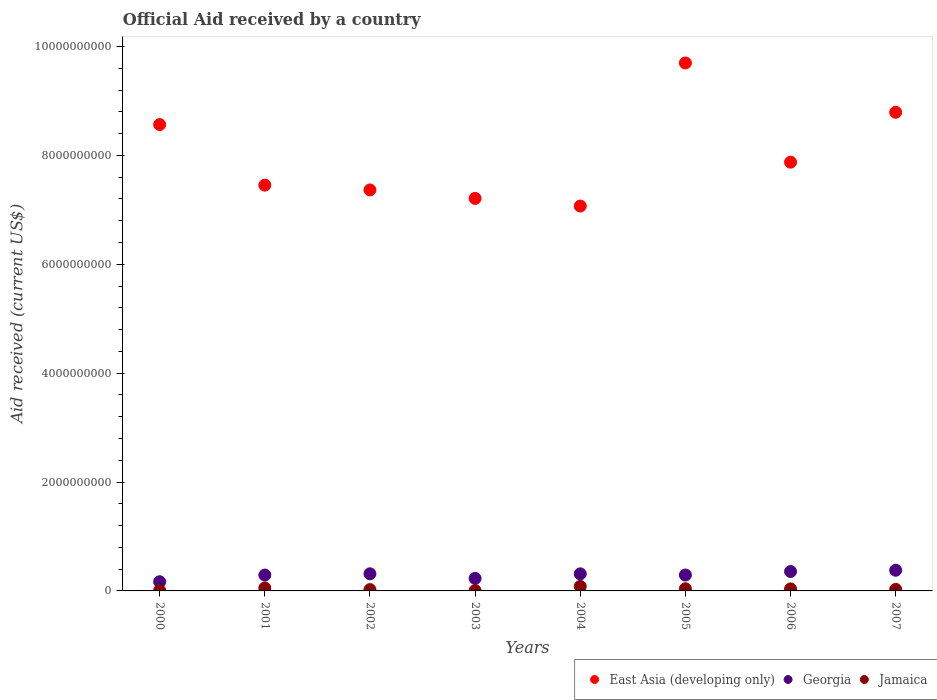How many different coloured dotlines are there?
Your response must be concise. 3. What is the net official aid received in Georgia in 2004?
Your response must be concise. 3.13e+08. Across all years, what is the maximum net official aid received in Jamaica?
Offer a very short reply. 8.26e+07. Across all years, what is the minimum net official aid received in Georgia?
Offer a terse response. 1.69e+08. What is the total net official aid received in Georgia in the graph?
Offer a very short reply. 2.35e+09. What is the difference between the net official aid received in Jamaica in 2002 and that in 2005?
Give a very brief answer. -1.56e+07. What is the difference between the net official aid received in Jamaica in 2002 and the net official aid received in Georgia in 2000?
Offer a terse response. -1.45e+08. What is the average net official aid received in East Asia (developing only) per year?
Provide a short and direct response. 8.00e+09. In the year 2006, what is the difference between the net official aid received in East Asia (developing only) and net official aid received in Georgia?
Make the answer very short. 7.52e+09. In how many years, is the net official aid received in East Asia (developing only) greater than 7200000000 US$?
Provide a short and direct response. 7. What is the ratio of the net official aid received in Georgia in 2000 to that in 2005?
Your answer should be very brief. 0.58. Is the net official aid received in Jamaica in 2004 less than that in 2007?
Make the answer very short. No. What is the difference between the highest and the second highest net official aid received in Jamaica?
Provide a succinct answer. 2.86e+07. What is the difference between the highest and the lowest net official aid received in Jamaica?
Make the answer very short. 7.61e+07. Is the sum of the net official aid received in East Asia (developing only) in 2000 and 2001 greater than the maximum net official aid received in Jamaica across all years?
Provide a short and direct response. Yes. Is it the case that in every year, the sum of the net official aid received in Georgia and net official aid received in East Asia (developing only)  is greater than the net official aid received in Jamaica?
Your answer should be very brief. Yes. Is the net official aid received in East Asia (developing only) strictly greater than the net official aid received in Jamaica over the years?
Provide a short and direct response. Yes. How many years are there in the graph?
Provide a succinct answer. 8. What is the difference between two consecutive major ticks on the Y-axis?
Your answer should be very brief. 2.00e+09. Are the values on the major ticks of Y-axis written in scientific E-notation?
Ensure brevity in your answer.  No. Where does the legend appear in the graph?
Your answer should be compact. Bottom right. What is the title of the graph?
Your answer should be very brief. Official Aid received by a country. Does "Lithuania" appear as one of the legend labels in the graph?
Your response must be concise. No. What is the label or title of the X-axis?
Your answer should be very brief. Years. What is the label or title of the Y-axis?
Make the answer very short. Aid received (current US$). What is the Aid received (current US$) of East Asia (developing only) in 2000?
Offer a terse response. 8.57e+09. What is the Aid received (current US$) in Georgia in 2000?
Provide a short and direct response. 1.69e+08. What is the Aid received (current US$) of Jamaica in 2000?
Give a very brief answer. 8.56e+06. What is the Aid received (current US$) in East Asia (developing only) in 2001?
Offer a very short reply. 7.45e+09. What is the Aid received (current US$) of Georgia in 2001?
Offer a terse response. 2.91e+08. What is the Aid received (current US$) of Jamaica in 2001?
Your response must be concise. 5.40e+07. What is the Aid received (current US$) in East Asia (developing only) in 2002?
Keep it short and to the point. 7.36e+09. What is the Aid received (current US$) in Georgia in 2002?
Your answer should be very brief. 3.14e+08. What is the Aid received (current US$) of Jamaica in 2002?
Make the answer very short. 2.40e+07. What is the Aid received (current US$) in East Asia (developing only) in 2003?
Your answer should be very brief. 7.21e+09. What is the Aid received (current US$) in Georgia in 2003?
Give a very brief answer. 2.30e+08. What is the Aid received (current US$) in Jamaica in 2003?
Offer a very short reply. 6.52e+06. What is the Aid received (current US$) of East Asia (developing only) in 2004?
Give a very brief answer. 7.07e+09. What is the Aid received (current US$) in Georgia in 2004?
Offer a very short reply. 3.13e+08. What is the Aid received (current US$) in Jamaica in 2004?
Make the answer very short. 8.26e+07. What is the Aid received (current US$) in East Asia (developing only) in 2005?
Your answer should be compact. 9.70e+09. What is the Aid received (current US$) in Georgia in 2005?
Offer a terse response. 2.92e+08. What is the Aid received (current US$) of Jamaica in 2005?
Provide a succinct answer. 3.96e+07. What is the Aid received (current US$) of East Asia (developing only) in 2006?
Ensure brevity in your answer.  7.87e+09. What is the Aid received (current US$) of Georgia in 2006?
Offer a very short reply. 3.56e+08. What is the Aid received (current US$) of Jamaica in 2006?
Your answer should be compact. 3.72e+07. What is the Aid received (current US$) in East Asia (developing only) in 2007?
Give a very brief answer. 8.79e+09. What is the Aid received (current US$) in Georgia in 2007?
Give a very brief answer. 3.80e+08. What is the Aid received (current US$) in Jamaica in 2007?
Your answer should be very brief. 2.81e+07. Across all years, what is the maximum Aid received (current US$) of East Asia (developing only)?
Your answer should be compact. 9.70e+09. Across all years, what is the maximum Aid received (current US$) in Georgia?
Provide a succinct answer. 3.80e+08. Across all years, what is the maximum Aid received (current US$) in Jamaica?
Provide a succinct answer. 8.26e+07. Across all years, what is the minimum Aid received (current US$) of East Asia (developing only)?
Offer a terse response. 7.07e+09. Across all years, what is the minimum Aid received (current US$) of Georgia?
Your answer should be very brief. 1.69e+08. Across all years, what is the minimum Aid received (current US$) in Jamaica?
Provide a short and direct response. 6.52e+06. What is the total Aid received (current US$) in East Asia (developing only) in the graph?
Offer a very short reply. 6.40e+1. What is the total Aid received (current US$) of Georgia in the graph?
Keep it short and to the point. 2.35e+09. What is the total Aid received (current US$) of Jamaica in the graph?
Ensure brevity in your answer.  2.81e+08. What is the difference between the Aid received (current US$) in East Asia (developing only) in 2000 and that in 2001?
Your answer should be compact. 1.11e+09. What is the difference between the Aid received (current US$) in Georgia in 2000 and that in 2001?
Provide a short and direct response. -1.22e+08. What is the difference between the Aid received (current US$) in Jamaica in 2000 and that in 2001?
Make the answer very short. -4.54e+07. What is the difference between the Aid received (current US$) in East Asia (developing only) in 2000 and that in 2002?
Provide a succinct answer. 1.20e+09. What is the difference between the Aid received (current US$) in Georgia in 2000 and that in 2002?
Your answer should be very brief. -1.45e+08. What is the difference between the Aid received (current US$) of Jamaica in 2000 and that in 2002?
Provide a short and direct response. -1.55e+07. What is the difference between the Aid received (current US$) in East Asia (developing only) in 2000 and that in 2003?
Offer a terse response. 1.36e+09. What is the difference between the Aid received (current US$) in Georgia in 2000 and that in 2003?
Keep it short and to the point. -6.09e+07. What is the difference between the Aid received (current US$) of Jamaica in 2000 and that in 2003?
Give a very brief answer. 2.04e+06. What is the difference between the Aid received (current US$) in East Asia (developing only) in 2000 and that in 2004?
Your answer should be compact. 1.50e+09. What is the difference between the Aid received (current US$) of Georgia in 2000 and that in 2004?
Your answer should be very brief. -1.44e+08. What is the difference between the Aid received (current US$) in Jamaica in 2000 and that in 2004?
Your answer should be compact. -7.41e+07. What is the difference between the Aid received (current US$) of East Asia (developing only) in 2000 and that in 2005?
Offer a very short reply. -1.13e+09. What is the difference between the Aid received (current US$) in Georgia in 2000 and that in 2005?
Offer a terse response. -1.23e+08. What is the difference between the Aid received (current US$) in Jamaica in 2000 and that in 2005?
Provide a succinct answer. -3.10e+07. What is the difference between the Aid received (current US$) in East Asia (developing only) in 2000 and that in 2006?
Your answer should be compact. 6.91e+08. What is the difference between the Aid received (current US$) in Georgia in 2000 and that in 2006?
Offer a very short reply. -1.87e+08. What is the difference between the Aid received (current US$) in Jamaica in 2000 and that in 2006?
Give a very brief answer. -2.86e+07. What is the difference between the Aid received (current US$) in East Asia (developing only) in 2000 and that in 2007?
Keep it short and to the point. -2.26e+08. What is the difference between the Aid received (current US$) of Georgia in 2000 and that in 2007?
Offer a very short reply. -2.10e+08. What is the difference between the Aid received (current US$) in Jamaica in 2000 and that in 2007?
Provide a succinct answer. -1.95e+07. What is the difference between the Aid received (current US$) in East Asia (developing only) in 2001 and that in 2002?
Make the answer very short. 8.78e+07. What is the difference between the Aid received (current US$) of Georgia in 2001 and that in 2002?
Make the answer very short. -2.31e+07. What is the difference between the Aid received (current US$) of Jamaica in 2001 and that in 2002?
Your response must be concise. 3.00e+07. What is the difference between the Aid received (current US$) of East Asia (developing only) in 2001 and that in 2003?
Keep it short and to the point. 2.44e+08. What is the difference between the Aid received (current US$) of Georgia in 2001 and that in 2003?
Your answer should be very brief. 6.13e+07. What is the difference between the Aid received (current US$) of Jamaica in 2001 and that in 2003?
Make the answer very short. 4.75e+07. What is the difference between the Aid received (current US$) in East Asia (developing only) in 2001 and that in 2004?
Offer a terse response. 3.84e+08. What is the difference between the Aid received (current US$) of Georgia in 2001 and that in 2004?
Your response must be concise. -2.21e+07. What is the difference between the Aid received (current US$) in Jamaica in 2001 and that in 2004?
Keep it short and to the point. -2.86e+07. What is the difference between the Aid received (current US$) of East Asia (developing only) in 2001 and that in 2005?
Provide a short and direct response. -2.24e+09. What is the difference between the Aid received (current US$) in Georgia in 2001 and that in 2005?
Provide a succinct answer. -7.40e+05. What is the difference between the Aid received (current US$) of Jamaica in 2001 and that in 2005?
Make the answer very short. 1.44e+07. What is the difference between the Aid received (current US$) in East Asia (developing only) in 2001 and that in 2006?
Provide a succinct answer. -4.22e+08. What is the difference between the Aid received (current US$) of Georgia in 2001 and that in 2006?
Your answer should be compact. -6.48e+07. What is the difference between the Aid received (current US$) in Jamaica in 2001 and that in 2006?
Offer a very short reply. 1.68e+07. What is the difference between the Aid received (current US$) of East Asia (developing only) in 2001 and that in 2007?
Offer a terse response. -1.34e+09. What is the difference between the Aid received (current US$) in Georgia in 2001 and that in 2007?
Your answer should be compact. -8.83e+07. What is the difference between the Aid received (current US$) of Jamaica in 2001 and that in 2007?
Keep it short and to the point. 2.59e+07. What is the difference between the Aid received (current US$) in East Asia (developing only) in 2002 and that in 2003?
Offer a very short reply. 1.56e+08. What is the difference between the Aid received (current US$) of Georgia in 2002 and that in 2003?
Offer a very short reply. 8.44e+07. What is the difference between the Aid received (current US$) of Jamaica in 2002 and that in 2003?
Provide a succinct answer. 1.75e+07. What is the difference between the Aid received (current US$) of East Asia (developing only) in 2002 and that in 2004?
Offer a very short reply. 2.96e+08. What is the difference between the Aid received (current US$) of Georgia in 2002 and that in 2004?
Give a very brief answer. 1.02e+06. What is the difference between the Aid received (current US$) in Jamaica in 2002 and that in 2004?
Your answer should be very brief. -5.86e+07. What is the difference between the Aid received (current US$) of East Asia (developing only) in 2002 and that in 2005?
Provide a succinct answer. -2.33e+09. What is the difference between the Aid received (current US$) of Georgia in 2002 and that in 2005?
Your answer should be compact. 2.24e+07. What is the difference between the Aid received (current US$) in Jamaica in 2002 and that in 2005?
Provide a short and direct response. -1.56e+07. What is the difference between the Aid received (current US$) in East Asia (developing only) in 2002 and that in 2006?
Your answer should be compact. -5.09e+08. What is the difference between the Aid received (current US$) in Georgia in 2002 and that in 2006?
Offer a terse response. -4.17e+07. What is the difference between the Aid received (current US$) of Jamaica in 2002 and that in 2006?
Give a very brief answer. -1.32e+07. What is the difference between the Aid received (current US$) of East Asia (developing only) in 2002 and that in 2007?
Keep it short and to the point. -1.43e+09. What is the difference between the Aid received (current US$) in Georgia in 2002 and that in 2007?
Keep it short and to the point. -6.52e+07. What is the difference between the Aid received (current US$) in Jamaica in 2002 and that in 2007?
Offer a terse response. -4.06e+06. What is the difference between the Aid received (current US$) in East Asia (developing only) in 2003 and that in 2004?
Offer a terse response. 1.41e+08. What is the difference between the Aid received (current US$) of Georgia in 2003 and that in 2004?
Offer a terse response. -8.34e+07. What is the difference between the Aid received (current US$) of Jamaica in 2003 and that in 2004?
Give a very brief answer. -7.61e+07. What is the difference between the Aid received (current US$) in East Asia (developing only) in 2003 and that in 2005?
Offer a terse response. -2.49e+09. What is the difference between the Aid received (current US$) of Georgia in 2003 and that in 2005?
Provide a succinct answer. -6.21e+07. What is the difference between the Aid received (current US$) in Jamaica in 2003 and that in 2005?
Offer a very short reply. -3.31e+07. What is the difference between the Aid received (current US$) in East Asia (developing only) in 2003 and that in 2006?
Make the answer very short. -6.65e+08. What is the difference between the Aid received (current US$) of Georgia in 2003 and that in 2006?
Offer a very short reply. -1.26e+08. What is the difference between the Aid received (current US$) of Jamaica in 2003 and that in 2006?
Ensure brevity in your answer.  -3.07e+07. What is the difference between the Aid received (current US$) of East Asia (developing only) in 2003 and that in 2007?
Give a very brief answer. -1.58e+09. What is the difference between the Aid received (current US$) in Georgia in 2003 and that in 2007?
Your answer should be compact. -1.50e+08. What is the difference between the Aid received (current US$) of Jamaica in 2003 and that in 2007?
Provide a succinct answer. -2.16e+07. What is the difference between the Aid received (current US$) of East Asia (developing only) in 2004 and that in 2005?
Your answer should be very brief. -2.63e+09. What is the difference between the Aid received (current US$) in Georgia in 2004 and that in 2005?
Make the answer very short. 2.13e+07. What is the difference between the Aid received (current US$) in Jamaica in 2004 and that in 2005?
Offer a terse response. 4.30e+07. What is the difference between the Aid received (current US$) in East Asia (developing only) in 2004 and that in 2006?
Provide a short and direct response. -8.06e+08. What is the difference between the Aid received (current US$) in Georgia in 2004 and that in 2006?
Offer a very short reply. -4.27e+07. What is the difference between the Aid received (current US$) in Jamaica in 2004 and that in 2006?
Offer a terse response. 4.54e+07. What is the difference between the Aid received (current US$) of East Asia (developing only) in 2004 and that in 2007?
Make the answer very short. -1.72e+09. What is the difference between the Aid received (current US$) of Georgia in 2004 and that in 2007?
Make the answer very short. -6.62e+07. What is the difference between the Aid received (current US$) of Jamaica in 2004 and that in 2007?
Provide a succinct answer. 5.46e+07. What is the difference between the Aid received (current US$) in East Asia (developing only) in 2005 and that in 2006?
Offer a very short reply. 1.82e+09. What is the difference between the Aid received (current US$) of Georgia in 2005 and that in 2006?
Give a very brief answer. -6.40e+07. What is the difference between the Aid received (current US$) in Jamaica in 2005 and that in 2006?
Ensure brevity in your answer.  2.40e+06. What is the difference between the Aid received (current US$) of East Asia (developing only) in 2005 and that in 2007?
Offer a very short reply. 9.06e+08. What is the difference between the Aid received (current US$) of Georgia in 2005 and that in 2007?
Ensure brevity in your answer.  -8.76e+07. What is the difference between the Aid received (current US$) in Jamaica in 2005 and that in 2007?
Your response must be concise. 1.15e+07. What is the difference between the Aid received (current US$) in East Asia (developing only) in 2006 and that in 2007?
Your answer should be compact. -9.17e+08. What is the difference between the Aid received (current US$) in Georgia in 2006 and that in 2007?
Your answer should be very brief. -2.35e+07. What is the difference between the Aid received (current US$) in Jamaica in 2006 and that in 2007?
Provide a short and direct response. 9.11e+06. What is the difference between the Aid received (current US$) of East Asia (developing only) in 2000 and the Aid received (current US$) of Georgia in 2001?
Give a very brief answer. 8.27e+09. What is the difference between the Aid received (current US$) in East Asia (developing only) in 2000 and the Aid received (current US$) in Jamaica in 2001?
Ensure brevity in your answer.  8.51e+09. What is the difference between the Aid received (current US$) of Georgia in 2000 and the Aid received (current US$) of Jamaica in 2001?
Your answer should be compact. 1.15e+08. What is the difference between the Aid received (current US$) in East Asia (developing only) in 2000 and the Aid received (current US$) in Georgia in 2002?
Give a very brief answer. 8.25e+09. What is the difference between the Aid received (current US$) of East Asia (developing only) in 2000 and the Aid received (current US$) of Jamaica in 2002?
Give a very brief answer. 8.54e+09. What is the difference between the Aid received (current US$) in Georgia in 2000 and the Aid received (current US$) in Jamaica in 2002?
Offer a very short reply. 1.45e+08. What is the difference between the Aid received (current US$) of East Asia (developing only) in 2000 and the Aid received (current US$) of Georgia in 2003?
Ensure brevity in your answer.  8.34e+09. What is the difference between the Aid received (current US$) in East Asia (developing only) in 2000 and the Aid received (current US$) in Jamaica in 2003?
Offer a terse response. 8.56e+09. What is the difference between the Aid received (current US$) in Georgia in 2000 and the Aid received (current US$) in Jamaica in 2003?
Provide a short and direct response. 1.63e+08. What is the difference between the Aid received (current US$) of East Asia (developing only) in 2000 and the Aid received (current US$) of Georgia in 2004?
Provide a short and direct response. 8.25e+09. What is the difference between the Aid received (current US$) of East Asia (developing only) in 2000 and the Aid received (current US$) of Jamaica in 2004?
Provide a short and direct response. 8.48e+09. What is the difference between the Aid received (current US$) of Georgia in 2000 and the Aid received (current US$) of Jamaica in 2004?
Your answer should be compact. 8.65e+07. What is the difference between the Aid received (current US$) of East Asia (developing only) in 2000 and the Aid received (current US$) of Georgia in 2005?
Give a very brief answer. 8.27e+09. What is the difference between the Aid received (current US$) of East Asia (developing only) in 2000 and the Aid received (current US$) of Jamaica in 2005?
Your response must be concise. 8.53e+09. What is the difference between the Aid received (current US$) of Georgia in 2000 and the Aid received (current US$) of Jamaica in 2005?
Ensure brevity in your answer.  1.30e+08. What is the difference between the Aid received (current US$) in East Asia (developing only) in 2000 and the Aid received (current US$) in Georgia in 2006?
Your answer should be very brief. 8.21e+09. What is the difference between the Aid received (current US$) in East Asia (developing only) in 2000 and the Aid received (current US$) in Jamaica in 2006?
Give a very brief answer. 8.53e+09. What is the difference between the Aid received (current US$) of Georgia in 2000 and the Aid received (current US$) of Jamaica in 2006?
Provide a short and direct response. 1.32e+08. What is the difference between the Aid received (current US$) of East Asia (developing only) in 2000 and the Aid received (current US$) of Georgia in 2007?
Your answer should be very brief. 8.19e+09. What is the difference between the Aid received (current US$) in East Asia (developing only) in 2000 and the Aid received (current US$) in Jamaica in 2007?
Give a very brief answer. 8.54e+09. What is the difference between the Aid received (current US$) in Georgia in 2000 and the Aid received (current US$) in Jamaica in 2007?
Give a very brief answer. 1.41e+08. What is the difference between the Aid received (current US$) of East Asia (developing only) in 2001 and the Aid received (current US$) of Georgia in 2002?
Ensure brevity in your answer.  7.14e+09. What is the difference between the Aid received (current US$) in East Asia (developing only) in 2001 and the Aid received (current US$) in Jamaica in 2002?
Your answer should be very brief. 7.43e+09. What is the difference between the Aid received (current US$) in Georgia in 2001 and the Aid received (current US$) in Jamaica in 2002?
Provide a short and direct response. 2.67e+08. What is the difference between the Aid received (current US$) in East Asia (developing only) in 2001 and the Aid received (current US$) in Georgia in 2003?
Provide a short and direct response. 7.22e+09. What is the difference between the Aid received (current US$) in East Asia (developing only) in 2001 and the Aid received (current US$) in Jamaica in 2003?
Provide a short and direct response. 7.45e+09. What is the difference between the Aid received (current US$) of Georgia in 2001 and the Aid received (current US$) of Jamaica in 2003?
Make the answer very short. 2.85e+08. What is the difference between the Aid received (current US$) of East Asia (developing only) in 2001 and the Aid received (current US$) of Georgia in 2004?
Your answer should be compact. 7.14e+09. What is the difference between the Aid received (current US$) of East Asia (developing only) in 2001 and the Aid received (current US$) of Jamaica in 2004?
Your answer should be compact. 7.37e+09. What is the difference between the Aid received (current US$) in Georgia in 2001 and the Aid received (current US$) in Jamaica in 2004?
Provide a succinct answer. 2.09e+08. What is the difference between the Aid received (current US$) in East Asia (developing only) in 2001 and the Aid received (current US$) in Georgia in 2005?
Ensure brevity in your answer.  7.16e+09. What is the difference between the Aid received (current US$) in East Asia (developing only) in 2001 and the Aid received (current US$) in Jamaica in 2005?
Offer a very short reply. 7.41e+09. What is the difference between the Aid received (current US$) of Georgia in 2001 and the Aid received (current US$) of Jamaica in 2005?
Give a very brief answer. 2.52e+08. What is the difference between the Aid received (current US$) in East Asia (developing only) in 2001 and the Aid received (current US$) in Georgia in 2006?
Keep it short and to the point. 7.10e+09. What is the difference between the Aid received (current US$) of East Asia (developing only) in 2001 and the Aid received (current US$) of Jamaica in 2006?
Offer a very short reply. 7.42e+09. What is the difference between the Aid received (current US$) of Georgia in 2001 and the Aid received (current US$) of Jamaica in 2006?
Keep it short and to the point. 2.54e+08. What is the difference between the Aid received (current US$) in East Asia (developing only) in 2001 and the Aid received (current US$) in Georgia in 2007?
Keep it short and to the point. 7.07e+09. What is the difference between the Aid received (current US$) in East Asia (developing only) in 2001 and the Aid received (current US$) in Jamaica in 2007?
Keep it short and to the point. 7.42e+09. What is the difference between the Aid received (current US$) in Georgia in 2001 and the Aid received (current US$) in Jamaica in 2007?
Your response must be concise. 2.63e+08. What is the difference between the Aid received (current US$) in East Asia (developing only) in 2002 and the Aid received (current US$) in Georgia in 2003?
Provide a succinct answer. 7.13e+09. What is the difference between the Aid received (current US$) of East Asia (developing only) in 2002 and the Aid received (current US$) of Jamaica in 2003?
Offer a very short reply. 7.36e+09. What is the difference between the Aid received (current US$) of Georgia in 2002 and the Aid received (current US$) of Jamaica in 2003?
Offer a very short reply. 3.08e+08. What is the difference between the Aid received (current US$) of East Asia (developing only) in 2002 and the Aid received (current US$) of Georgia in 2004?
Ensure brevity in your answer.  7.05e+09. What is the difference between the Aid received (current US$) in East Asia (developing only) in 2002 and the Aid received (current US$) in Jamaica in 2004?
Ensure brevity in your answer.  7.28e+09. What is the difference between the Aid received (current US$) in Georgia in 2002 and the Aid received (current US$) in Jamaica in 2004?
Provide a succinct answer. 2.32e+08. What is the difference between the Aid received (current US$) in East Asia (developing only) in 2002 and the Aid received (current US$) in Georgia in 2005?
Offer a very short reply. 7.07e+09. What is the difference between the Aid received (current US$) in East Asia (developing only) in 2002 and the Aid received (current US$) in Jamaica in 2005?
Offer a terse response. 7.33e+09. What is the difference between the Aid received (current US$) of Georgia in 2002 and the Aid received (current US$) of Jamaica in 2005?
Keep it short and to the point. 2.75e+08. What is the difference between the Aid received (current US$) in East Asia (developing only) in 2002 and the Aid received (current US$) in Georgia in 2006?
Provide a succinct answer. 7.01e+09. What is the difference between the Aid received (current US$) in East Asia (developing only) in 2002 and the Aid received (current US$) in Jamaica in 2006?
Your response must be concise. 7.33e+09. What is the difference between the Aid received (current US$) in Georgia in 2002 and the Aid received (current US$) in Jamaica in 2006?
Offer a very short reply. 2.77e+08. What is the difference between the Aid received (current US$) in East Asia (developing only) in 2002 and the Aid received (current US$) in Georgia in 2007?
Offer a terse response. 6.99e+09. What is the difference between the Aid received (current US$) in East Asia (developing only) in 2002 and the Aid received (current US$) in Jamaica in 2007?
Your answer should be compact. 7.34e+09. What is the difference between the Aid received (current US$) in Georgia in 2002 and the Aid received (current US$) in Jamaica in 2007?
Give a very brief answer. 2.86e+08. What is the difference between the Aid received (current US$) in East Asia (developing only) in 2003 and the Aid received (current US$) in Georgia in 2004?
Your response must be concise. 6.90e+09. What is the difference between the Aid received (current US$) of East Asia (developing only) in 2003 and the Aid received (current US$) of Jamaica in 2004?
Give a very brief answer. 7.13e+09. What is the difference between the Aid received (current US$) of Georgia in 2003 and the Aid received (current US$) of Jamaica in 2004?
Provide a short and direct response. 1.47e+08. What is the difference between the Aid received (current US$) of East Asia (developing only) in 2003 and the Aid received (current US$) of Georgia in 2005?
Your answer should be compact. 6.92e+09. What is the difference between the Aid received (current US$) in East Asia (developing only) in 2003 and the Aid received (current US$) in Jamaica in 2005?
Keep it short and to the point. 7.17e+09. What is the difference between the Aid received (current US$) of Georgia in 2003 and the Aid received (current US$) of Jamaica in 2005?
Ensure brevity in your answer.  1.90e+08. What is the difference between the Aid received (current US$) of East Asia (developing only) in 2003 and the Aid received (current US$) of Georgia in 2006?
Your answer should be compact. 6.85e+09. What is the difference between the Aid received (current US$) in East Asia (developing only) in 2003 and the Aid received (current US$) in Jamaica in 2006?
Make the answer very short. 7.17e+09. What is the difference between the Aid received (current US$) in Georgia in 2003 and the Aid received (current US$) in Jamaica in 2006?
Make the answer very short. 1.93e+08. What is the difference between the Aid received (current US$) in East Asia (developing only) in 2003 and the Aid received (current US$) in Georgia in 2007?
Your response must be concise. 6.83e+09. What is the difference between the Aid received (current US$) in East Asia (developing only) in 2003 and the Aid received (current US$) in Jamaica in 2007?
Offer a very short reply. 7.18e+09. What is the difference between the Aid received (current US$) in Georgia in 2003 and the Aid received (current US$) in Jamaica in 2007?
Your answer should be compact. 2.02e+08. What is the difference between the Aid received (current US$) of East Asia (developing only) in 2004 and the Aid received (current US$) of Georgia in 2005?
Offer a very short reply. 6.78e+09. What is the difference between the Aid received (current US$) of East Asia (developing only) in 2004 and the Aid received (current US$) of Jamaica in 2005?
Give a very brief answer. 7.03e+09. What is the difference between the Aid received (current US$) of Georgia in 2004 and the Aid received (current US$) of Jamaica in 2005?
Offer a terse response. 2.74e+08. What is the difference between the Aid received (current US$) of East Asia (developing only) in 2004 and the Aid received (current US$) of Georgia in 2006?
Make the answer very short. 6.71e+09. What is the difference between the Aid received (current US$) in East Asia (developing only) in 2004 and the Aid received (current US$) in Jamaica in 2006?
Make the answer very short. 7.03e+09. What is the difference between the Aid received (current US$) in Georgia in 2004 and the Aid received (current US$) in Jamaica in 2006?
Your response must be concise. 2.76e+08. What is the difference between the Aid received (current US$) in East Asia (developing only) in 2004 and the Aid received (current US$) in Georgia in 2007?
Ensure brevity in your answer.  6.69e+09. What is the difference between the Aid received (current US$) of East Asia (developing only) in 2004 and the Aid received (current US$) of Jamaica in 2007?
Keep it short and to the point. 7.04e+09. What is the difference between the Aid received (current US$) of Georgia in 2004 and the Aid received (current US$) of Jamaica in 2007?
Give a very brief answer. 2.85e+08. What is the difference between the Aid received (current US$) of East Asia (developing only) in 2005 and the Aid received (current US$) of Georgia in 2006?
Offer a terse response. 9.34e+09. What is the difference between the Aid received (current US$) of East Asia (developing only) in 2005 and the Aid received (current US$) of Jamaica in 2006?
Your answer should be compact. 9.66e+09. What is the difference between the Aid received (current US$) of Georgia in 2005 and the Aid received (current US$) of Jamaica in 2006?
Offer a terse response. 2.55e+08. What is the difference between the Aid received (current US$) of East Asia (developing only) in 2005 and the Aid received (current US$) of Georgia in 2007?
Your response must be concise. 9.32e+09. What is the difference between the Aid received (current US$) in East Asia (developing only) in 2005 and the Aid received (current US$) in Jamaica in 2007?
Offer a very short reply. 9.67e+09. What is the difference between the Aid received (current US$) of Georgia in 2005 and the Aid received (current US$) of Jamaica in 2007?
Your response must be concise. 2.64e+08. What is the difference between the Aid received (current US$) in East Asia (developing only) in 2006 and the Aid received (current US$) in Georgia in 2007?
Provide a succinct answer. 7.49e+09. What is the difference between the Aid received (current US$) of East Asia (developing only) in 2006 and the Aid received (current US$) of Jamaica in 2007?
Provide a succinct answer. 7.85e+09. What is the difference between the Aid received (current US$) of Georgia in 2006 and the Aid received (current US$) of Jamaica in 2007?
Keep it short and to the point. 3.28e+08. What is the average Aid received (current US$) in East Asia (developing only) per year?
Your answer should be compact. 8.00e+09. What is the average Aid received (current US$) of Georgia per year?
Ensure brevity in your answer.  2.93e+08. What is the average Aid received (current US$) of Jamaica per year?
Ensure brevity in your answer.  3.51e+07. In the year 2000, what is the difference between the Aid received (current US$) of East Asia (developing only) and Aid received (current US$) of Georgia?
Ensure brevity in your answer.  8.40e+09. In the year 2000, what is the difference between the Aid received (current US$) of East Asia (developing only) and Aid received (current US$) of Jamaica?
Give a very brief answer. 8.56e+09. In the year 2000, what is the difference between the Aid received (current US$) of Georgia and Aid received (current US$) of Jamaica?
Ensure brevity in your answer.  1.61e+08. In the year 2001, what is the difference between the Aid received (current US$) in East Asia (developing only) and Aid received (current US$) in Georgia?
Give a very brief answer. 7.16e+09. In the year 2001, what is the difference between the Aid received (current US$) of East Asia (developing only) and Aid received (current US$) of Jamaica?
Your answer should be compact. 7.40e+09. In the year 2001, what is the difference between the Aid received (current US$) of Georgia and Aid received (current US$) of Jamaica?
Give a very brief answer. 2.37e+08. In the year 2002, what is the difference between the Aid received (current US$) in East Asia (developing only) and Aid received (current US$) in Georgia?
Give a very brief answer. 7.05e+09. In the year 2002, what is the difference between the Aid received (current US$) of East Asia (developing only) and Aid received (current US$) of Jamaica?
Give a very brief answer. 7.34e+09. In the year 2002, what is the difference between the Aid received (current US$) of Georgia and Aid received (current US$) of Jamaica?
Provide a short and direct response. 2.90e+08. In the year 2003, what is the difference between the Aid received (current US$) of East Asia (developing only) and Aid received (current US$) of Georgia?
Offer a terse response. 6.98e+09. In the year 2003, what is the difference between the Aid received (current US$) of East Asia (developing only) and Aid received (current US$) of Jamaica?
Make the answer very short. 7.20e+09. In the year 2003, what is the difference between the Aid received (current US$) of Georgia and Aid received (current US$) of Jamaica?
Your answer should be very brief. 2.23e+08. In the year 2004, what is the difference between the Aid received (current US$) of East Asia (developing only) and Aid received (current US$) of Georgia?
Offer a terse response. 6.75e+09. In the year 2004, what is the difference between the Aid received (current US$) in East Asia (developing only) and Aid received (current US$) in Jamaica?
Offer a terse response. 6.99e+09. In the year 2004, what is the difference between the Aid received (current US$) of Georgia and Aid received (current US$) of Jamaica?
Keep it short and to the point. 2.31e+08. In the year 2005, what is the difference between the Aid received (current US$) of East Asia (developing only) and Aid received (current US$) of Georgia?
Offer a very short reply. 9.40e+09. In the year 2005, what is the difference between the Aid received (current US$) of East Asia (developing only) and Aid received (current US$) of Jamaica?
Provide a succinct answer. 9.66e+09. In the year 2005, what is the difference between the Aid received (current US$) of Georgia and Aid received (current US$) of Jamaica?
Your answer should be very brief. 2.52e+08. In the year 2006, what is the difference between the Aid received (current US$) of East Asia (developing only) and Aid received (current US$) of Georgia?
Provide a succinct answer. 7.52e+09. In the year 2006, what is the difference between the Aid received (current US$) of East Asia (developing only) and Aid received (current US$) of Jamaica?
Offer a very short reply. 7.84e+09. In the year 2006, what is the difference between the Aid received (current US$) of Georgia and Aid received (current US$) of Jamaica?
Keep it short and to the point. 3.19e+08. In the year 2007, what is the difference between the Aid received (current US$) of East Asia (developing only) and Aid received (current US$) of Georgia?
Keep it short and to the point. 8.41e+09. In the year 2007, what is the difference between the Aid received (current US$) in East Asia (developing only) and Aid received (current US$) in Jamaica?
Offer a terse response. 8.76e+09. In the year 2007, what is the difference between the Aid received (current US$) in Georgia and Aid received (current US$) in Jamaica?
Keep it short and to the point. 3.52e+08. What is the ratio of the Aid received (current US$) in East Asia (developing only) in 2000 to that in 2001?
Provide a succinct answer. 1.15. What is the ratio of the Aid received (current US$) of Georgia in 2000 to that in 2001?
Provide a short and direct response. 0.58. What is the ratio of the Aid received (current US$) of Jamaica in 2000 to that in 2001?
Keep it short and to the point. 0.16. What is the ratio of the Aid received (current US$) in East Asia (developing only) in 2000 to that in 2002?
Keep it short and to the point. 1.16. What is the ratio of the Aid received (current US$) of Georgia in 2000 to that in 2002?
Provide a succinct answer. 0.54. What is the ratio of the Aid received (current US$) in Jamaica in 2000 to that in 2002?
Keep it short and to the point. 0.36. What is the ratio of the Aid received (current US$) of East Asia (developing only) in 2000 to that in 2003?
Make the answer very short. 1.19. What is the ratio of the Aid received (current US$) in Georgia in 2000 to that in 2003?
Provide a succinct answer. 0.74. What is the ratio of the Aid received (current US$) of Jamaica in 2000 to that in 2003?
Ensure brevity in your answer.  1.31. What is the ratio of the Aid received (current US$) of East Asia (developing only) in 2000 to that in 2004?
Your answer should be compact. 1.21. What is the ratio of the Aid received (current US$) in Georgia in 2000 to that in 2004?
Offer a terse response. 0.54. What is the ratio of the Aid received (current US$) of Jamaica in 2000 to that in 2004?
Provide a succinct answer. 0.1. What is the ratio of the Aid received (current US$) of East Asia (developing only) in 2000 to that in 2005?
Provide a succinct answer. 0.88. What is the ratio of the Aid received (current US$) of Georgia in 2000 to that in 2005?
Offer a terse response. 0.58. What is the ratio of the Aid received (current US$) of Jamaica in 2000 to that in 2005?
Provide a succinct answer. 0.22. What is the ratio of the Aid received (current US$) in East Asia (developing only) in 2000 to that in 2006?
Keep it short and to the point. 1.09. What is the ratio of the Aid received (current US$) of Georgia in 2000 to that in 2006?
Offer a terse response. 0.47. What is the ratio of the Aid received (current US$) in Jamaica in 2000 to that in 2006?
Give a very brief answer. 0.23. What is the ratio of the Aid received (current US$) of East Asia (developing only) in 2000 to that in 2007?
Your response must be concise. 0.97. What is the ratio of the Aid received (current US$) of Georgia in 2000 to that in 2007?
Offer a terse response. 0.45. What is the ratio of the Aid received (current US$) of Jamaica in 2000 to that in 2007?
Provide a short and direct response. 0.3. What is the ratio of the Aid received (current US$) of East Asia (developing only) in 2001 to that in 2002?
Offer a terse response. 1.01. What is the ratio of the Aid received (current US$) in Georgia in 2001 to that in 2002?
Offer a terse response. 0.93. What is the ratio of the Aid received (current US$) in Jamaica in 2001 to that in 2002?
Your response must be concise. 2.25. What is the ratio of the Aid received (current US$) in East Asia (developing only) in 2001 to that in 2003?
Provide a short and direct response. 1.03. What is the ratio of the Aid received (current US$) in Georgia in 2001 to that in 2003?
Keep it short and to the point. 1.27. What is the ratio of the Aid received (current US$) in Jamaica in 2001 to that in 2003?
Make the answer very short. 8.28. What is the ratio of the Aid received (current US$) in East Asia (developing only) in 2001 to that in 2004?
Provide a succinct answer. 1.05. What is the ratio of the Aid received (current US$) in Georgia in 2001 to that in 2004?
Provide a short and direct response. 0.93. What is the ratio of the Aid received (current US$) in Jamaica in 2001 to that in 2004?
Your answer should be very brief. 0.65. What is the ratio of the Aid received (current US$) in East Asia (developing only) in 2001 to that in 2005?
Offer a very short reply. 0.77. What is the ratio of the Aid received (current US$) in Jamaica in 2001 to that in 2005?
Your response must be concise. 1.36. What is the ratio of the Aid received (current US$) in East Asia (developing only) in 2001 to that in 2006?
Ensure brevity in your answer.  0.95. What is the ratio of the Aid received (current US$) of Georgia in 2001 to that in 2006?
Make the answer very short. 0.82. What is the ratio of the Aid received (current US$) in Jamaica in 2001 to that in 2006?
Ensure brevity in your answer.  1.45. What is the ratio of the Aid received (current US$) of East Asia (developing only) in 2001 to that in 2007?
Offer a terse response. 0.85. What is the ratio of the Aid received (current US$) of Georgia in 2001 to that in 2007?
Provide a short and direct response. 0.77. What is the ratio of the Aid received (current US$) of Jamaica in 2001 to that in 2007?
Give a very brief answer. 1.92. What is the ratio of the Aid received (current US$) of East Asia (developing only) in 2002 to that in 2003?
Make the answer very short. 1.02. What is the ratio of the Aid received (current US$) of Georgia in 2002 to that in 2003?
Give a very brief answer. 1.37. What is the ratio of the Aid received (current US$) of Jamaica in 2002 to that in 2003?
Give a very brief answer. 3.68. What is the ratio of the Aid received (current US$) in East Asia (developing only) in 2002 to that in 2004?
Keep it short and to the point. 1.04. What is the ratio of the Aid received (current US$) of Georgia in 2002 to that in 2004?
Your answer should be very brief. 1. What is the ratio of the Aid received (current US$) in Jamaica in 2002 to that in 2004?
Your answer should be compact. 0.29. What is the ratio of the Aid received (current US$) in East Asia (developing only) in 2002 to that in 2005?
Provide a short and direct response. 0.76. What is the ratio of the Aid received (current US$) in Georgia in 2002 to that in 2005?
Offer a terse response. 1.08. What is the ratio of the Aid received (current US$) of Jamaica in 2002 to that in 2005?
Offer a very short reply. 0.61. What is the ratio of the Aid received (current US$) of East Asia (developing only) in 2002 to that in 2006?
Keep it short and to the point. 0.94. What is the ratio of the Aid received (current US$) of Georgia in 2002 to that in 2006?
Your answer should be very brief. 0.88. What is the ratio of the Aid received (current US$) in Jamaica in 2002 to that in 2006?
Make the answer very short. 0.65. What is the ratio of the Aid received (current US$) of East Asia (developing only) in 2002 to that in 2007?
Keep it short and to the point. 0.84. What is the ratio of the Aid received (current US$) in Georgia in 2002 to that in 2007?
Keep it short and to the point. 0.83. What is the ratio of the Aid received (current US$) of Jamaica in 2002 to that in 2007?
Keep it short and to the point. 0.86. What is the ratio of the Aid received (current US$) of East Asia (developing only) in 2003 to that in 2004?
Offer a terse response. 1.02. What is the ratio of the Aid received (current US$) in Georgia in 2003 to that in 2004?
Make the answer very short. 0.73. What is the ratio of the Aid received (current US$) of Jamaica in 2003 to that in 2004?
Your answer should be very brief. 0.08. What is the ratio of the Aid received (current US$) of East Asia (developing only) in 2003 to that in 2005?
Offer a terse response. 0.74. What is the ratio of the Aid received (current US$) of Georgia in 2003 to that in 2005?
Your answer should be very brief. 0.79. What is the ratio of the Aid received (current US$) in Jamaica in 2003 to that in 2005?
Your response must be concise. 0.16. What is the ratio of the Aid received (current US$) in East Asia (developing only) in 2003 to that in 2006?
Ensure brevity in your answer.  0.92. What is the ratio of the Aid received (current US$) of Georgia in 2003 to that in 2006?
Your answer should be compact. 0.65. What is the ratio of the Aid received (current US$) in Jamaica in 2003 to that in 2006?
Keep it short and to the point. 0.18. What is the ratio of the Aid received (current US$) of East Asia (developing only) in 2003 to that in 2007?
Offer a very short reply. 0.82. What is the ratio of the Aid received (current US$) of Georgia in 2003 to that in 2007?
Offer a very short reply. 0.61. What is the ratio of the Aid received (current US$) in Jamaica in 2003 to that in 2007?
Provide a succinct answer. 0.23. What is the ratio of the Aid received (current US$) of East Asia (developing only) in 2004 to that in 2005?
Offer a very short reply. 0.73. What is the ratio of the Aid received (current US$) in Georgia in 2004 to that in 2005?
Your response must be concise. 1.07. What is the ratio of the Aid received (current US$) of Jamaica in 2004 to that in 2005?
Give a very brief answer. 2.09. What is the ratio of the Aid received (current US$) of East Asia (developing only) in 2004 to that in 2006?
Ensure brevity in your answer.  0.9. What is the ratio of the Aid received (current US$) in Jamaica in 2004 to that in 2006?
Offer a very short reply. 2.22. What is the ratio of the Aid received (current US$) of East Asia (developing only) in 2004 to that in 2007?
Give a very brief answer. 0.8. What is the ratio of the Aid received (current US$) of Georgia in 2004 to that in 2007?
Your response must be concise. 0.83. What is the ratio of the Aid received (current US$) in Jamaica in 2004 to that in 2007?
Offer a terse response. 2.94. What is the ratio of the Aid received (current US$) in East Asia (developing only) in 2005 to that in 2006?
Your answer should be very brief. 1.23. What is the ratio of the Aid received (current US$) in Georgia in 2005 to that in 2006?
Offer a terse response. 0.82. What is the ratio of the Aid received (current US$) in Jamaica in 2005 to that in 2006?
Keep it short and to the point. 1.06. What is the ratio of the Aid received (current US$) of East Asia (developing only) in 2005 to that in 2007?
Keep it short and to the point. 1.1. What is the ratio of the Aid received (current US$) of Georgia in 2005 to that in 2007?
Give a very brief answer. 0.77. What is the ratio of the Aid received (current US$) in Jamaica in 2005 to that in 2007?
Keep it short and to the point. 1.41. What is the ratio of the Aid received (current US$) in East Asia (developing only) in 2006 to that in 2007?
Your response must be concise. 0.9. What is the ratio of the Aid received (current US$) of Georgia in 2006 to that in 2007?
Your answer should be very brief. 0.94. What is the ratio of the Aid received (current US$) of Jamaica in 2006 to that in 2007?
Offer a terse response. 1.32. What is the difference between the highest and the second highest Aid received (current US$) in East Asia (developing only)?
Make the answer very short. 9.06e+08. What is the difference between the highest and the second highest Aid received (current US$) in Georgia?
Make the answer very short. 2.35e+07. What is the difference between the highest and the second highest Aid received (current US$) in Jamaica?
Provide a short and direct response. 2.86e+07. What is the difference between the highest and the lowest Aid received (current US$) of East Asia (developing only)?
Make the answer very short. 2.63e+09. What is the difference between the highest and the lowest Aid received (current US$) in Georgia?
Provide a succinct answer. 2.10e+08. What is the difference between the highest and the lowest Aid received (current US$) in Jamaica?
Offer a very short reply. 7.61e+07. 